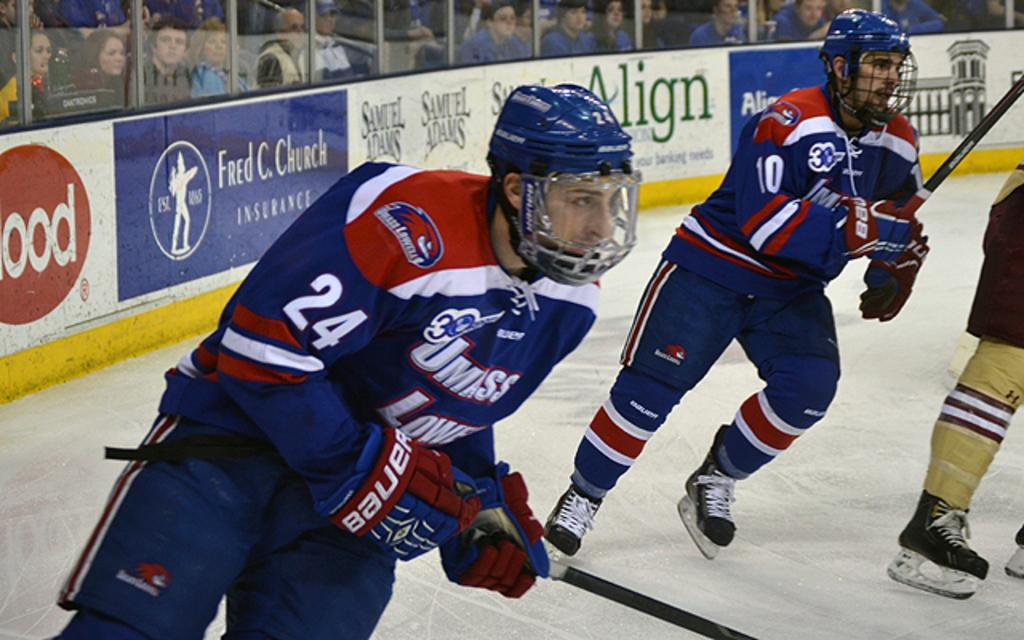What sport are the people playing in the image? The people are playing Ice hockey in the image. What protective gear are the players wearing? The players are wearing helmets in the image. Can you describe any additional features in the image? There are boards with text in the image. Who else is present in the image besides the players? There is an audience visible in the image. How many ladybugs can be seen crawling on the ice in the image? There are no ladybugs present in the image; it features a game of Ice hockey. What type of insect is crawling on the players' sticks in the image? There are no insects present in the image, and the players are not holding any sticks. 